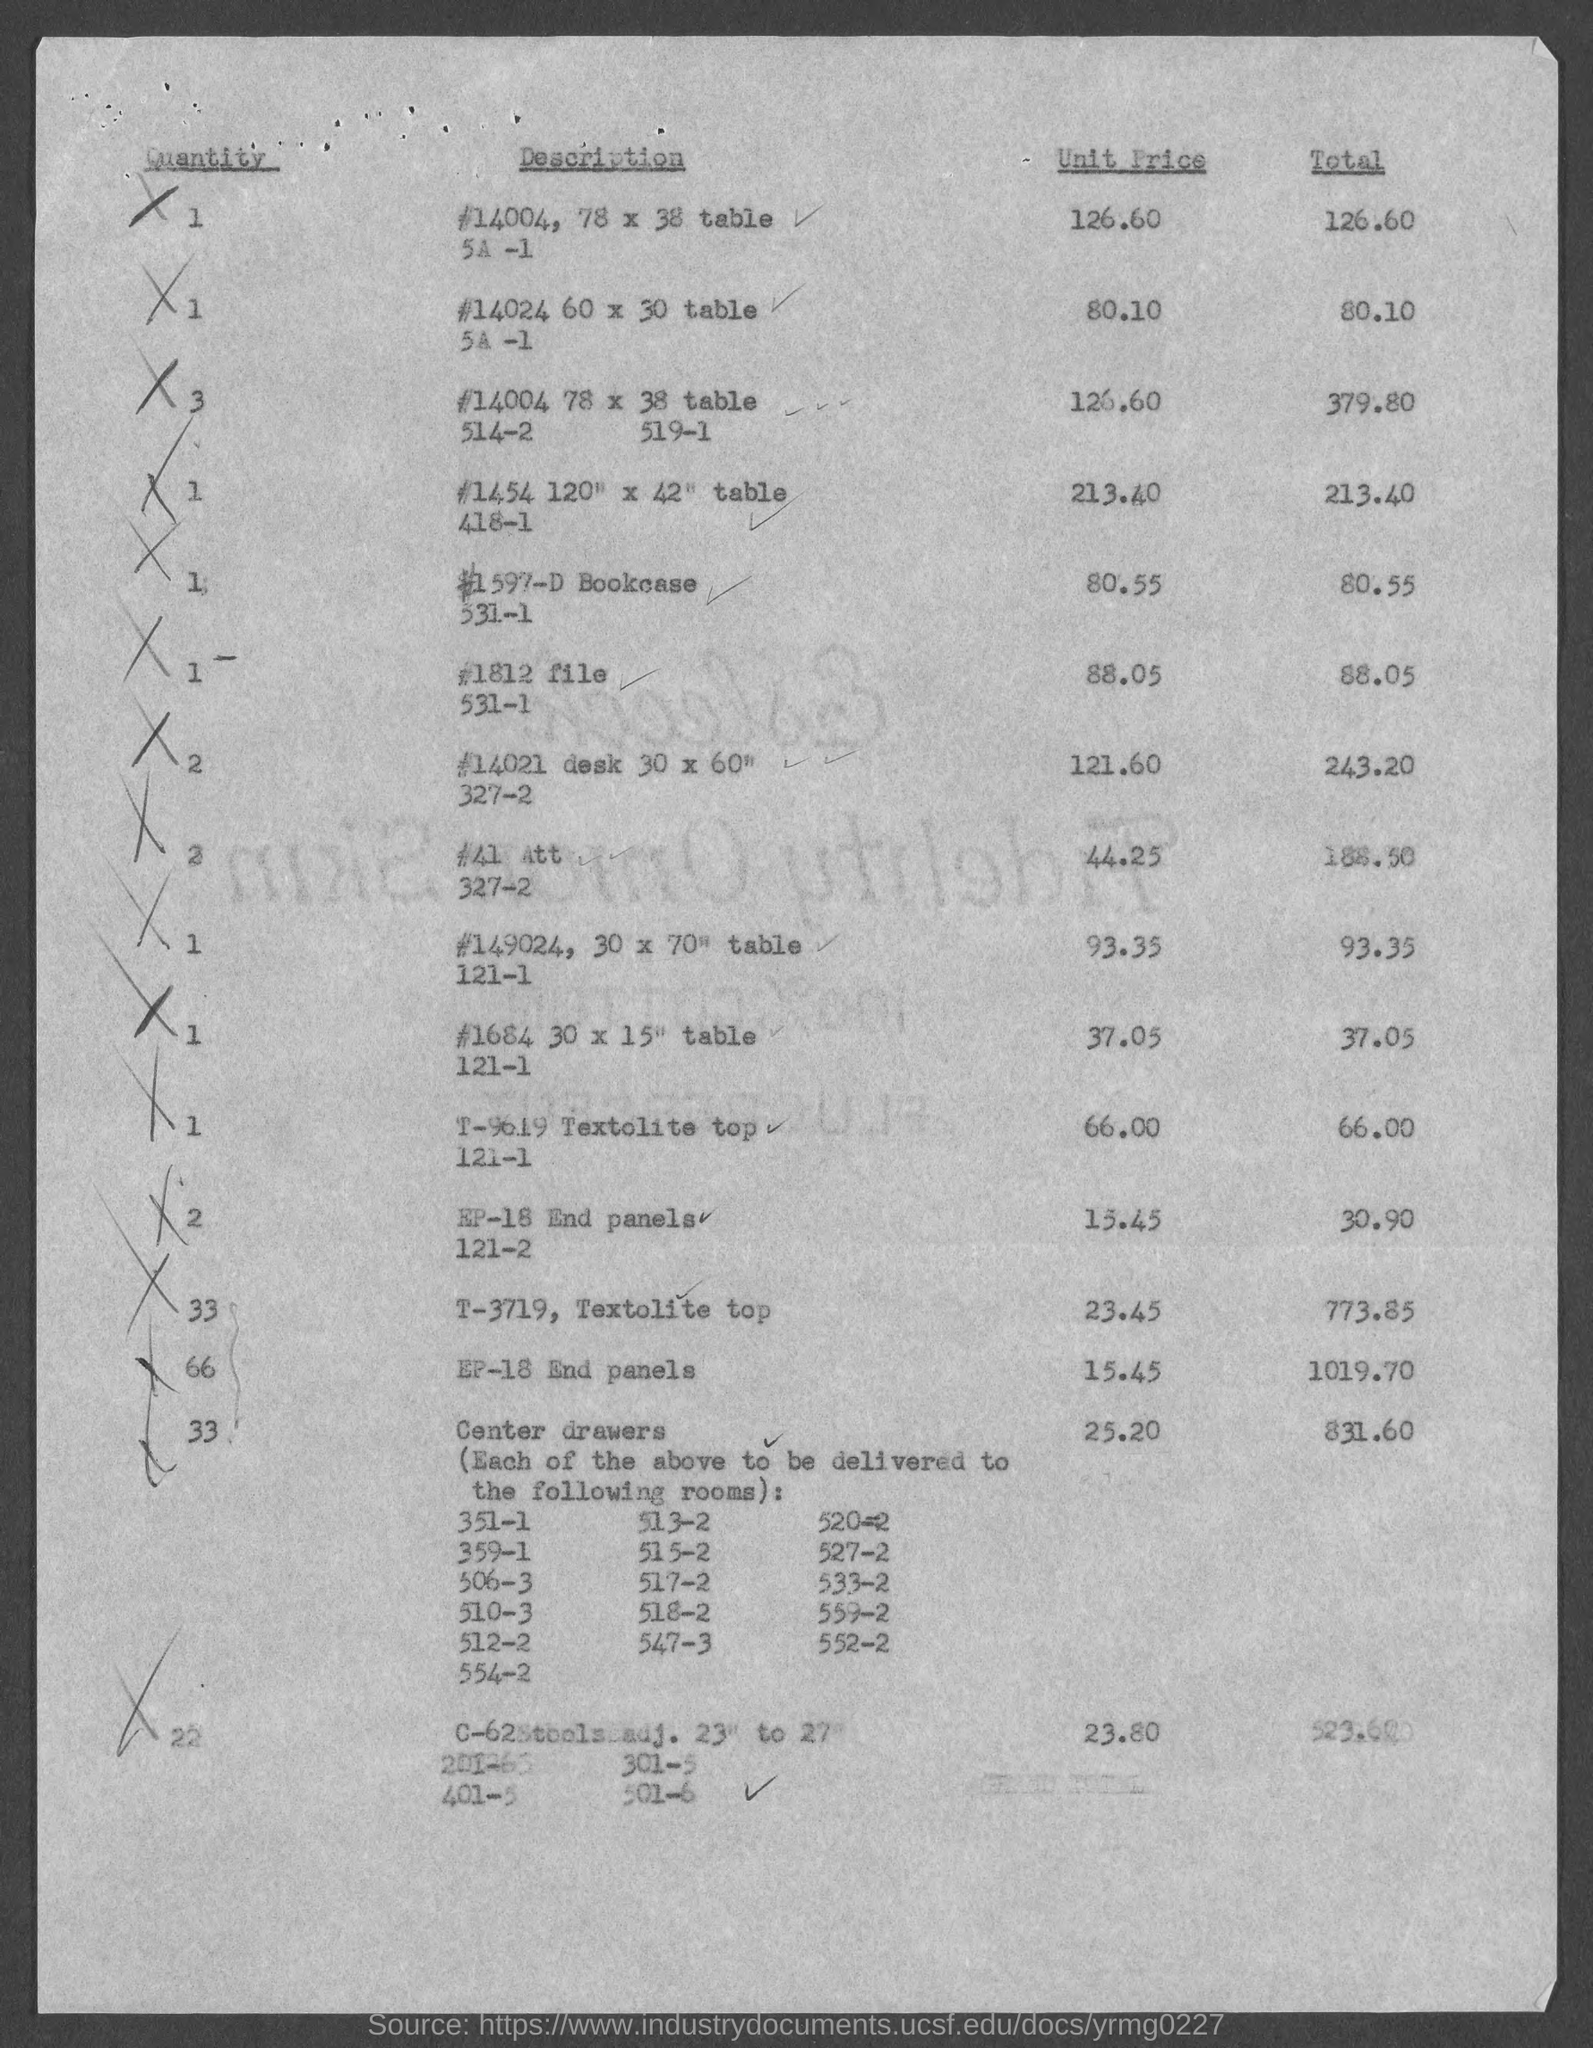Highlight a few significant elements in this photo. The table size in the second row of description is 60 inches wide and 30 inches long. The unit price in the first row of the table is 126.60. The total value for end panels EP 18 is 1019.70 The quantity in the third row of the table is three. The quantity in the last row is 22. 